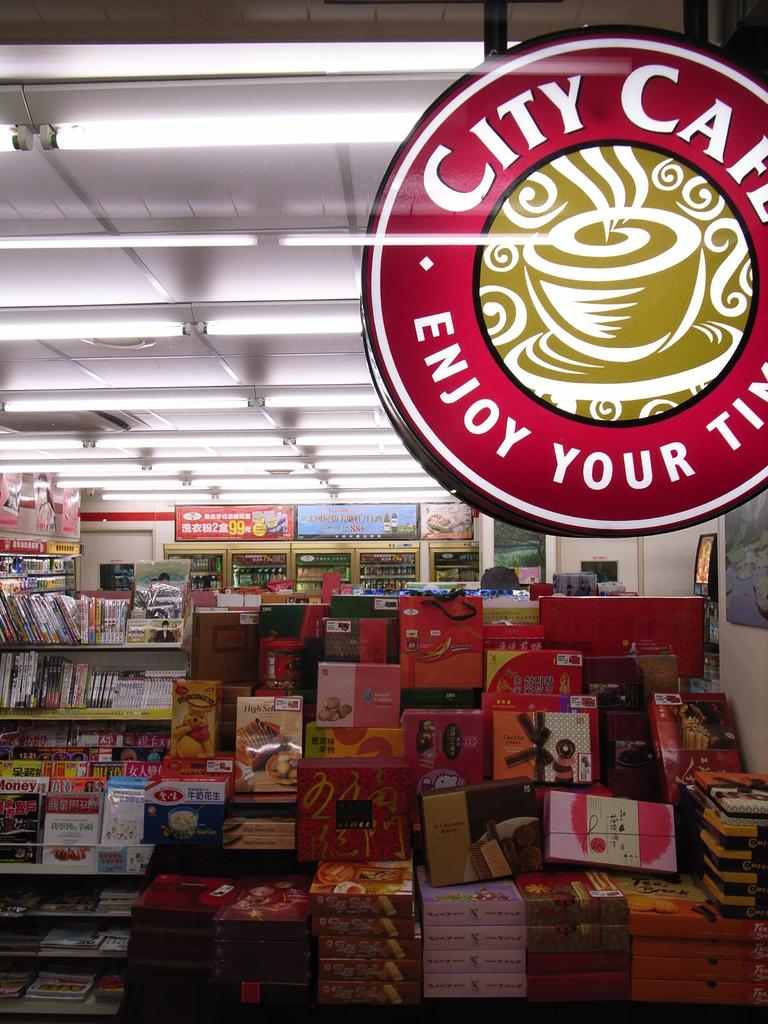What type of location is depicted in the image? The image appears to be taken in a supermarket. What can be seen in the front of the image? There are racks with items in the front of the image. What part of the building can be seen in the image? The roof is visible in the image. What is present on the roof? Lights are present on the roof. Can you see any clovers growing on the floor in the image? There are no clovers visible in the image; it is taken in a supermarket, not a field or garden. 